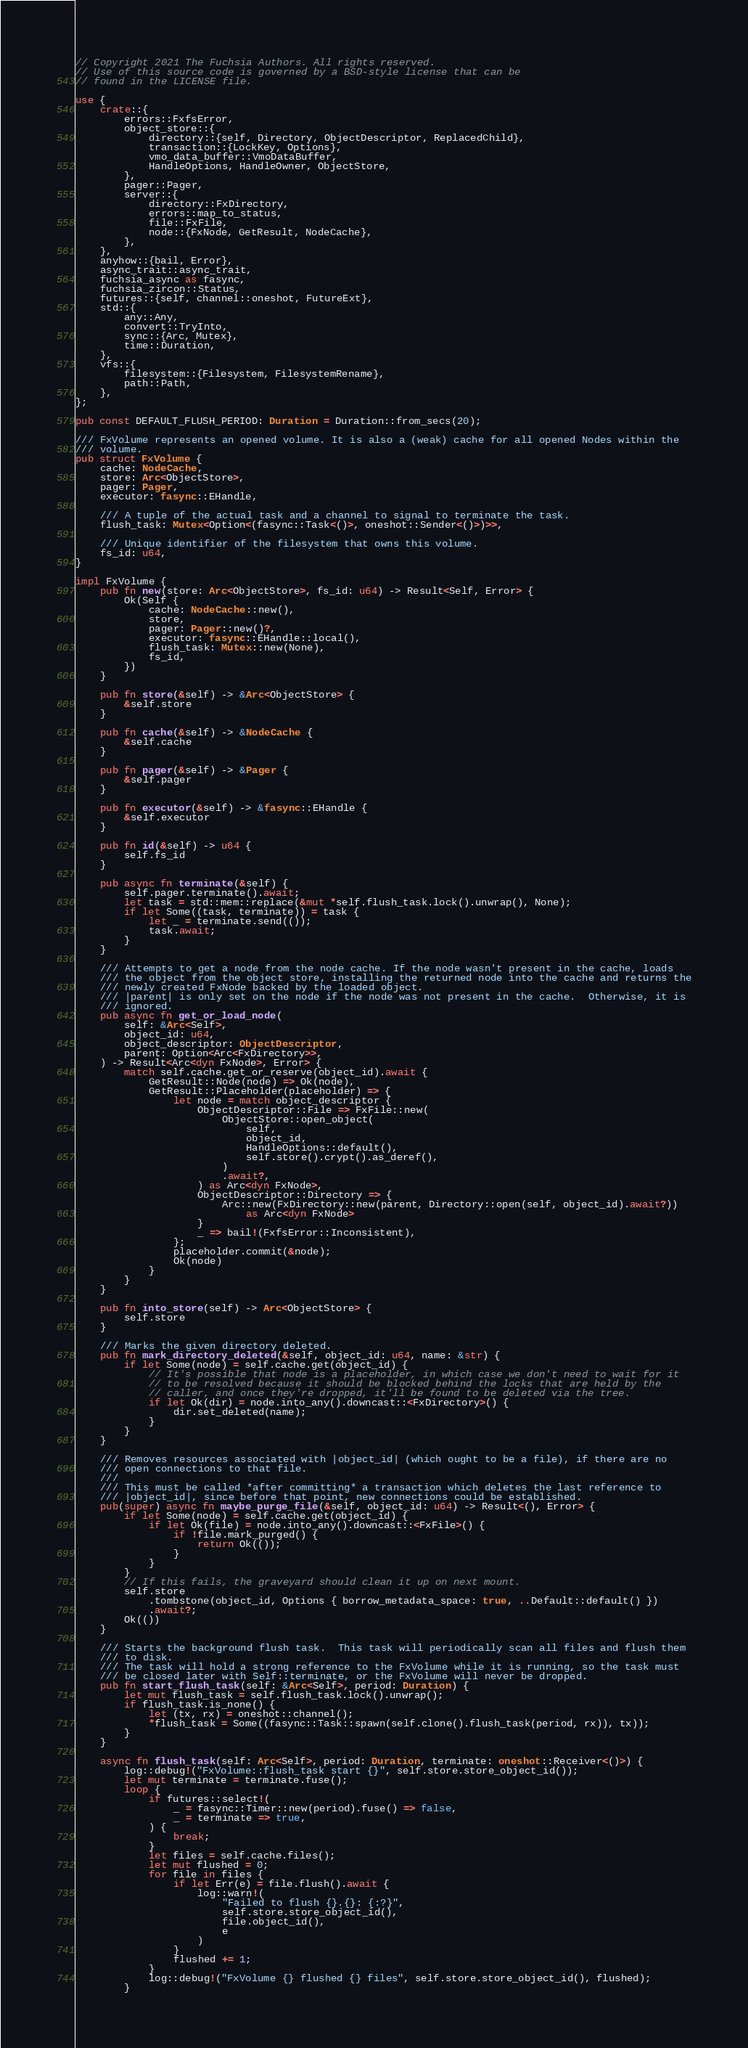Convert code to text. <code><loc_0><loc_0><loc_500><loc_500><_Rust_>// Copyright 2021 The Fuchsia Authors. All rights reserved.
// Use of this source code is governed by a BSD-style license that can be
// found in the LICENSE file.

use {
    crate::{
        errors::FxfsError,
        object_store::{
            directory::{self, Directory, ObjectDescriptor, ReplacedChild},
            transaction::{LockKey, Options},
            vmo_data_buffer::VmoDataBuffer,
            HandleOptions, HandleOwner, ObjectStore,
        },
        pager::Pager,
        server::{
            directory::FxDirectory,
            errors::map_to_status,
            file::FxFile,
            node::{FxNode, GetResult, NodeCache},
        },
    },
    anyhow::{bail, Error},
    async_trait::async_trait,
    fuchsia_async as fasync,
    fuchsia_zircon::Status,
    futures::{self, channel::oneshot, FutureExt},
    std::{
        any::Any,
        convert::TryInto,
        sync::{Arc, Mutex},
        time::Duration,
    },
    vfs::{
        filesystem::{Filesystem, FilesystemRename},
        path::Path,
    },
};

pub const DEFAULT_FLUSH_PERIOD: Duration = Duration::from_secs(20);

/// FxVolume represents an opened volume. It is also a (weak) cache for all opened Nodes within the
/// volume.
pub struct FxVolume {
    cache: NodeCache,
    store: Arc<ObjectStore>,
    pager: Pager,
    executor: fasync::EHandle,

    /// A tuple of the actual task and a channel to signal to terminate the task.
    flush_task: Mutex<Option<(fasync::Task<()>, oneshot::Sender<()>)>>,

    /// Unique identifier of the filesystem that owns this volume.
    fs_id: u64,
}

impl FxVolume {
    pub fn new(store: Arc<ObjectStore>, fs_id: u64) -> Result<Self, Error> {
        Ok(Self {
            cache: NodeCache::new(),
            store,
            pager: Pager::new()?,
            executor: fasync::EHandle::local(),
            flush_task: Mutex::new(None),
            fs_id,
        })
    }

    pub fn store(&self) -> &Arc<ObjectStore> {
        &self.store
    }

    pub fn cache(&self) -> &NodeCache {
        &self.cache
    }

    pub fn pager(&self) -> &Pager {
        &self.pager
    }

    pub fn executor(&self) -> &fasync::EHandle {
        &self.executor
    }

    pub fn id(&self) -> u64 {
        self.fs_id
    }

    pub async fn terminate(&self) {
        self.pager.terminate().await;
        let task = std::mem::replace(&mut *self.flush_task.lock().unwrap(), None);
        if let Some((task, terminate)) = task {
            let _ = terminate.send(());
            task.await;
        }
    }

    /// Attempts to get a node from the node cache. If the node wasn't present in the cache, loads
    /// the object from the object store, installing the returned node into the cache and returns the
    /// newly created FxNode backed by the loaded object.
    /// |parent| is only set on the node if the node was not present in the cache.  Otherwise, it is
    /// ignored.
    pub async fn get_or_load_node(
        self: &Arc<Self>,
        object_id: u64,
        object_descriptor: ObjectDescriptor,
        parent: Option<Arc<FxDirectory>>,
    ) -> Result<Arc<dyn FxNode>, Error> {
        match self.cache.get_or_reserve(object_id).await {
            GetResult::Node(node) => Ok(node),
            GetResult::Placeholder(placeholder) => {
                let node = match object_descriptor {
                    ObjectDescriptor::File => FxFile::new(
                        ObjectStore::open_object(
                            self,
                            object_id,
                            HandleOptions::default(),
                            self.store().crypt().as_deref(),
                        )
                        .await?,
                    ) as Arc<dyn FxNode>,
                    ObjectDescriptor::Directory => {
                        Arc::new(FxDirectory::new(parent, Directory::open(self, object_id).await?))
                            as Arc<dyn FxNode>
                    }
                    _ => bail!(FxfsError::Inconsistent),
                };
                placeholder.commit(&node);
                Ok(node)
            }
        }
    }

    pub fn into_store(self) -> Arc<ObjectStore> {
        self.store
    }

    /// Marks the given directory deleted.
    pub fn mark_directory_deleted(&self, object_id: u64, name: &str) {
        if let Some(node) = self.cache.get(object_id) {
            // It's possible that node is a placeholder, in which case we don't need to wait for it
            // to be resolved because it should be blocked behind the locks that are held by the
            // caller, and once they're dropped, it'll be found to be deleted via the tree.
            if let Ok(dir) = node.into_any().downcast::<FxDirectory>() {
                dir.set_deleted(name);
            }
        }
    }

    /// Removes resources associated with |object_id| (which ought to be a file), if there are no
    /// open connections to that file.
    ///
    /// This must be called *after committing* a transaction which deletes the last reference to
    /// |object_id|, since before that point, new connections could be established.
    pub(super) async fn maybe_purge_file(&self, object_id: u64) -> Result<(), Error> {
        if let Some(node) = self.cache.get(object_id) {
            if let Ok(file) = node.into_any().downcast::<FxFile>() {
                if !file.mark_purged() {
                    return Ok(());
                }
            }
        }
        // If this fails, the graveyard should clean it up on next mount.
        self.store
            .tombstone(object_id, Options { borrow_metadata_space: true, ..Default::default() })
            .await?;
        Ok(())
    }

    /// Starts the background flush task.  This task will periodically scan all files and flush them
    /// to disk.
    /// The task will hold a strong reference to the FxVolume while it is running, so the task must
    /// be closed later with Self::terminate, or the FxVolume will never be dropped.
    pub fn start_flush_task(self: &Arc<Self>, period: Duration) {
        let mut flush_task = self.flush_task.lock().unwrap();
        if flush_task.is_none() {
            let (tx, rx) = oneshot::channel();
            *flush_task = Some((fasync::Task::spawn(self.clone().flush_task(period, rx)), tx));
        }
    }

    async fn flush_task(self: Arc<Self>, period: Duration, terminate: oneshot::Receiver<()>) {
        log::debug!("FxVolume::flush_task start {}", self.store.store_object_id());
        let mut terminate = terminate.fuse();
        loop {
            if futures::select!(
                _ = fasync::Timer::new(period).fuse() => false,
                _ = terminate => true,
            ) {
                break;
            }
            let files = self.cache.files();
            let mut flushed = 0;
            for file in files {
                if let Err(e) = file.flush().await {
                    log::warn!(
                        "Failed to flush {}.{}: {:?}",
                        self.store.store_object_id(),
                        file.object_id(),
                        e
                    )
                }
                flushed += 1;
            }
            log::debug!("FxVolume {} flushed {} files", self.store.store_object_id(), flushed);
        }</code> 